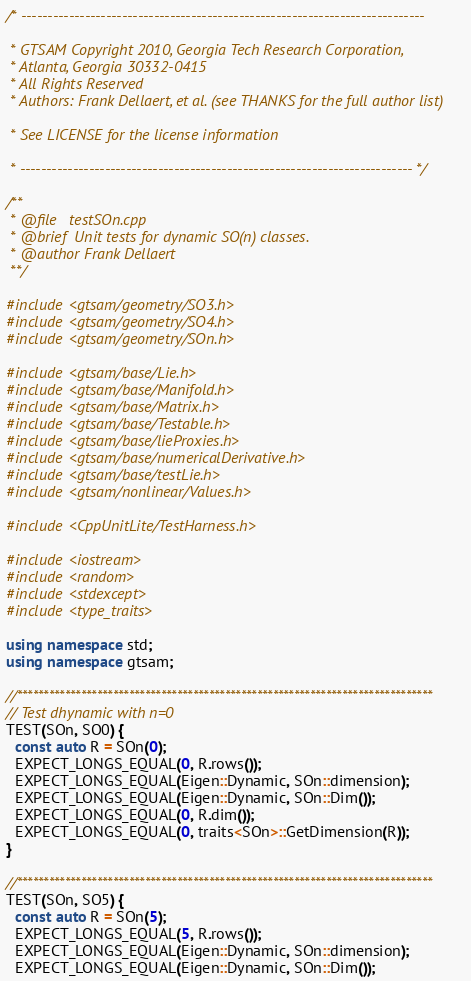<code> <loc_0><loc_0><loc_500><loc_500><_C++_>/* ----------------------------------------------------------------------------

 * GTSAM Copyright 2010, Georgia Tech Research Corporation,
 * Atlanta, Georgia 30332-0415
 * All Rights Reserved
 * Authors: Frank Dellaert, et al. (see THANKS for the full author list)

 * See LICENSE for the license information

 * -------------------------------------------------------------------------- */

/**
 * @file   testSOn.cpp
 * @brief  Unit tests for dynamic SO(n) classes.
 * @author Frank Dellaert
 **/

#include <gtsam/geometry/SO3.h>
#include <gtsam/geometry/SO4.h>
#include <gtsam/geometry/SOn.h>

#include <gtsam/base/Lie.h>
#include <gtsam/base/Manifold.h>
#include <gtsam/base/Matrix.h>
#include <gtsam/base/Testable.h>
#include <gtsam/base/lieProxies.h>
#include <gtsam/base/numericalDerivative.h>
#include <gtsam/base/testLie.h>
#include <gtsam/nonlinear/Values.h>

#include <CppUnitLite/TestHarness.h>

#include <iostream>
#include <random>
#include <stdexcept>
#include <type_traits>

using namespace std;
using namespace gtsam;

//******************************************************************************
// Test dhynamic with n=0
TEST(SOn, SO0) {
  const auto R = SOn(0);
  EXPECT_LONGS_EQUAL(0, R.rows());
  EXPECT_LONGS_EQUAL(Eigen::Dynamic, SOn::dimension);
  EXPECT_LONGS_EQUAL(Eigen::Dynamic, SOn::Dim());
  EXPECT_LONGS_EQUAL(0, R.dim());
  EXPECT_LONGS_EQUAL(0, traits<SOn>::GetDimension(R));
}

//******************************************************************************
TEST(SOn, SO5) {
  const auto R = SOn(5);
  EXPECT_LONGS_EQUAL(5, R.rows());
  EXPECT_LONGS_EQUAL(Eigen::Dynamic, SOn::dimension);
  EXPECT_LONGS_EQUAL(Eigen::Dynamic, SOn::Dim());</code> 